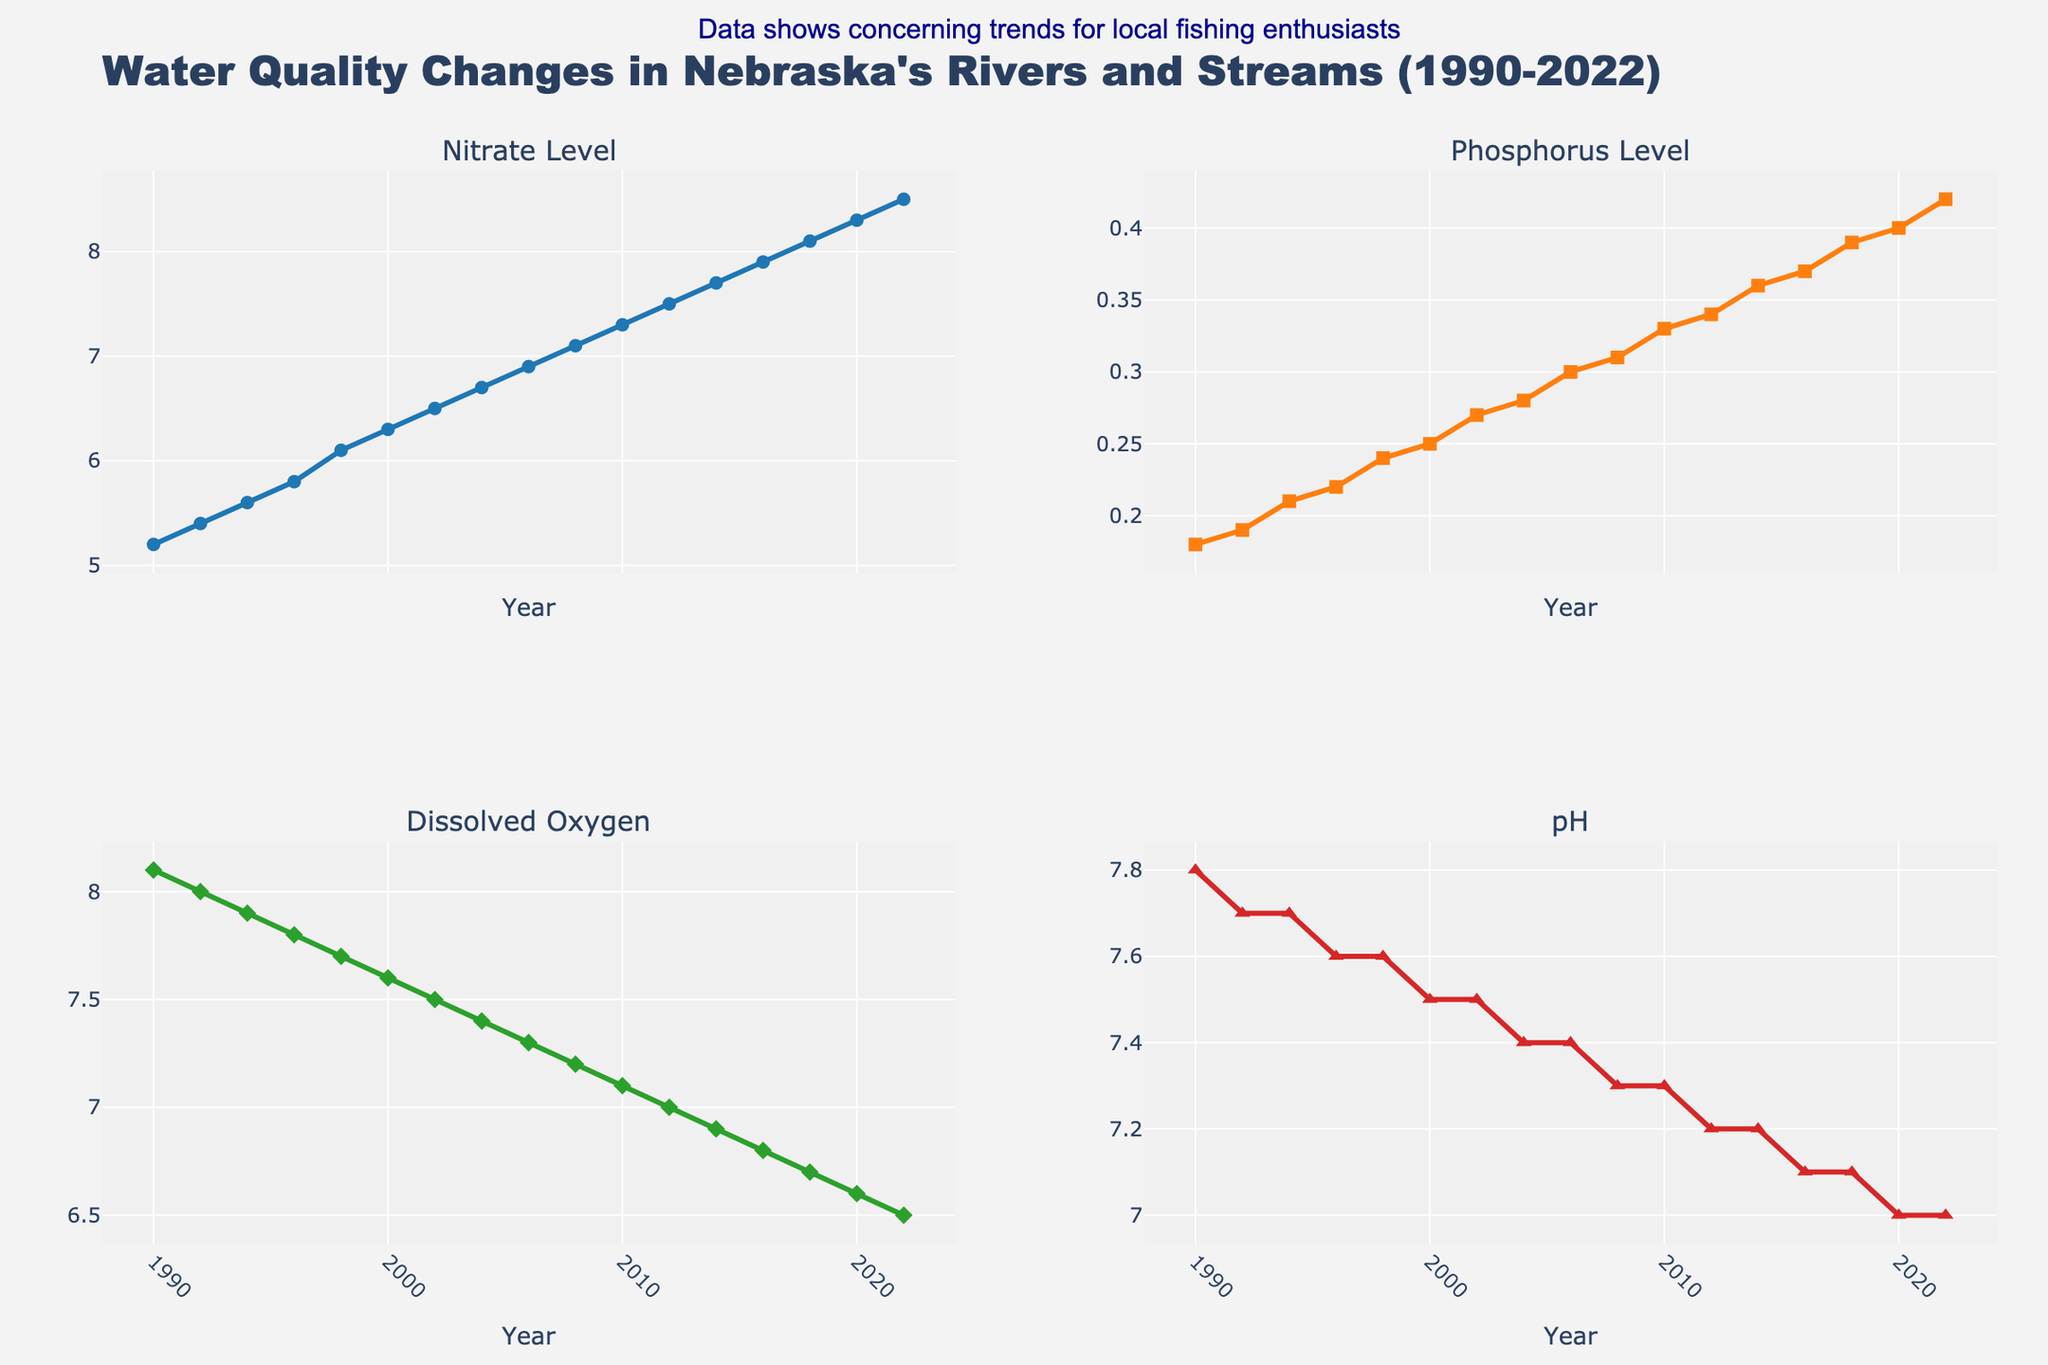What is the overall trend of the Nitrate Level from 1990 to 2022? From left to right in the Nitrate Level subplot, the line goes upwards, indicating an increasing trend.
Answer: Increasing Which year had the highest Dissolved Oxygen level, and what was it? In the Dissolved Oxygen subplot, the highest point is at the leftmost end, which corresponds to the year 1990, with a value of 8.1 mg/L.
Answer: 1990, 8.1 mg/L Compare the pH levels in 1990 and 2022. Which year had a higher pH, and by how much? In the pH subplot, the point for 1990 is higher than the point for 2022. Subtracting the values, 1990 had a pH of 7.8 and 2022 had 7.0, giving a difference of 0.8.
Answer: 1990, 0.8 higher What was the difference in Phosphorus Level between the years 2000 and 2018? In the Phosphorus Level subplot, locate 2000 with a value of 0.25 mg/L and 2018 with a value of 0.39 mg/L. Subtract 0.25 from 0.39 to get the difference.
Answer: 0.14 mg/L Calculate the average Dissolved Oxygen level from 1990 to 2022. Sum the Dissolved Oxygen values (8.1 + 8.0 + 7.9 + 7.8 + 7.7 + 7.6 + 7.5 + 7.4 + 7.3 + 7.2 + 7.1 + 7.0 + 6.9 + 6.8 + 6.7 + 6.6 + 6.5) and divide by the number of years (17). The sum is 118.6, and the average is 118.6 ÷ 17.
Answer: 6.98 mg/L Did the Phosphorus Level ever decrease from one recorded year to the next? Follow the Phosphorus Level subplot from left to right. The line consistently goes upwards, indicating no decrease.
Answer: No Between which consecutive years did the Nitrate Level increase the most? Examine the Nitrate Level subplot and find the steepest slope between consecutive years. The biggest increase is between 2020 (8.3 mg/L) and 2022 (8.5 mg/L), an increase of 0.2 mg/L.
Answer: 2020 and 2022 Contrast the trends of Dissolved Oxygen and pH levels from 1990 to 2022. Both the Dissolved Oxygen and pH level plots show a generally decreasing trend from 1990 to 2022, indicating a decline in water quality over time.
Answer: Both decreased What is the correlation between Nitrate Level and Phosphorus Level over the years? In both the Nitrate Level and Phosphorus Level subplots, the lines both show an upward trend, which suggests a positive correlation—they tend to increase together over the years.
Answer: Positive correlation What major observation can be made about the changes in water quality in Nebraska's rivers and streams? The overall trends indicate increasing Nitrate and Phosphorus levels and decreasing Dissolved Oxygen and pH levels, suggesting deteriorating water quality.
Answer: Deteriorating water quality 